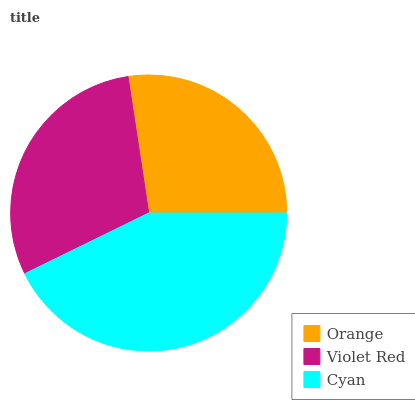Is Orange the minimum?
Answer yes or no. Yes. Is Cyan the maximum?
Answer yes or no. Yes. Is Violet Red the minimum?
Answer yes or no. No. Is Violet Red the maximum?
Answer yes or no. No. Is Violet Red greater than Orange?
Answer yes or no. Yes. Is Orange less than Violet Red?
Answer yes or no. Yes. Is Orange greater than Violet Red?
Answer yes or no. No. Is Violet Red less than Orange?
Answer yes or no. No. Is Violet Red the high median?
Answer yes or no. Yes. Is Violet Red the low median?
Answer yes or no. Yes. Is Orange the high median?
Answer yes or no. No. Is Orange the low median?
Answer yes or no. No. 